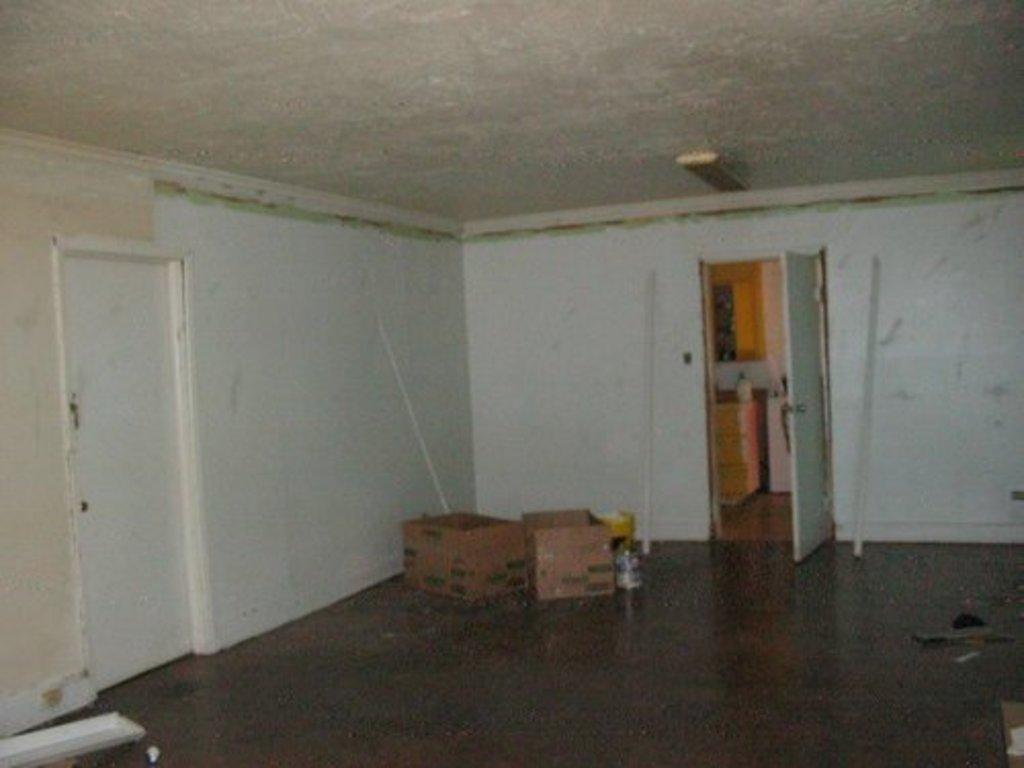Where was the image taken? The image was taken inside a room. What can be seen in the center of the picture? There are boxes in the center of the picture. What architectural features are visible on the left side of the image? There is a door and wall on the left side of the image. What architectural features are visible on the right side of the image? There is a door and walls on the right side of the image. What part of the room is visible at the top of the image? The ceiling is visible at the top of the image. How many wings can be seen on the rat in the image? There is no rat present in the image, and therefore no wings can be seen. 